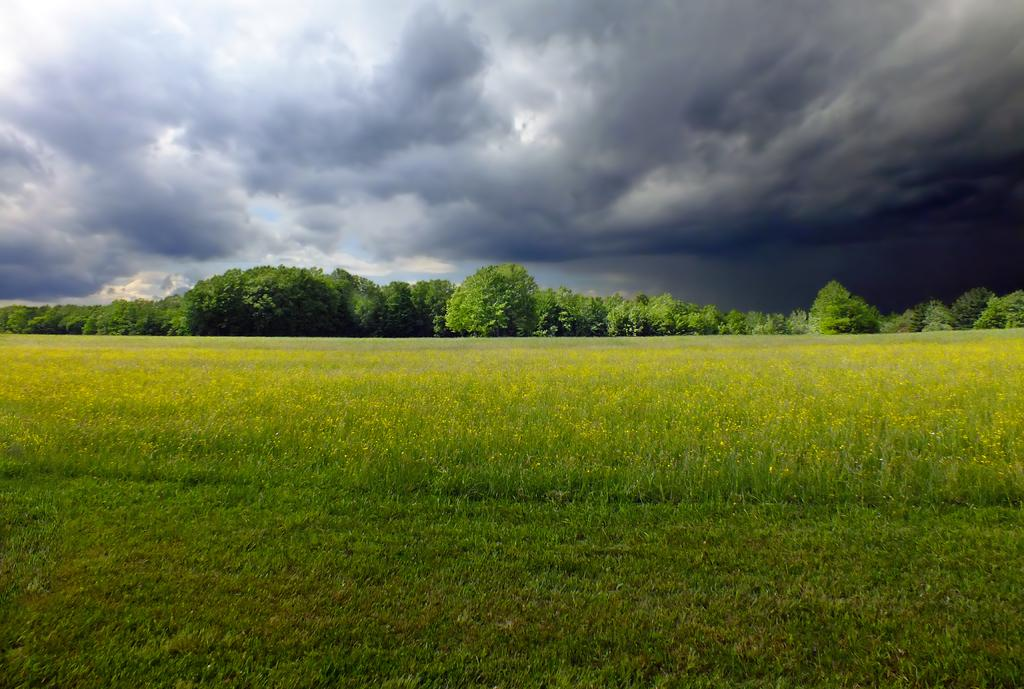What type of vegetation can be seen in the image? There are plants, grass, and trees in the image. What is visible at the top of the image? The sky is visible at the top of the image. What can be seen in the sky? Clouds are present in the sky. What type of sorting technique is being used by the mom in the image? There is no mom or sorting technique present in the image. Is the person driving a car in the image? There is no person or car present in the image. 